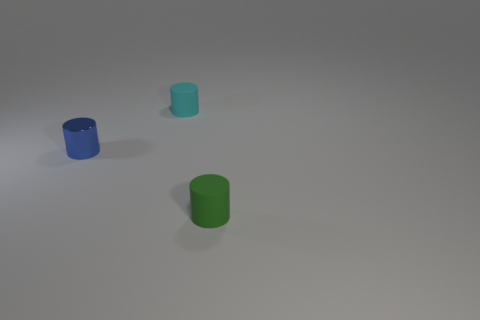What number of cylinders are small cyan things or tiny blue things?
Give a very brief answer. 2. Are there the same number of green things that are left of the cyan matte cylinder and cyan rubber things?
Your answer should be very brief. No. There is a tiny green thing in front of the small blue shiny thing in front of the tiny rubber object that is behind the green thing; what is its material?
Offer a very short reply. Rubber. What number of things are either tiny rubber objects behind the small green cylinder or blue blocks?
Offer a terse response. 1. What number of objects are small metallic cubes or tiny cylinders that are on the left side of the cyan object?
Your answer should be very brief. 1. There is a tiny matte cylinder in front of the rubber thing on the left side of the green matte object; how many rubber things are right of it?
Your response must be concise. 0. What is the material of the cyan thing that is the same size as the blue object?
Provide a succinct answer. Rubber. Are there any blue cylinders that have the same size as the green cylinder?
Ensure brevity in your answer.  Yes. The tiny metal object has what color?
Your answer should be very brief. Blue. There is a tiny rubber cylinder to the right of the small rubber thing to the left of the tiny green cylinder; what is its color?
Ensure brevity in your answer.  Green. 